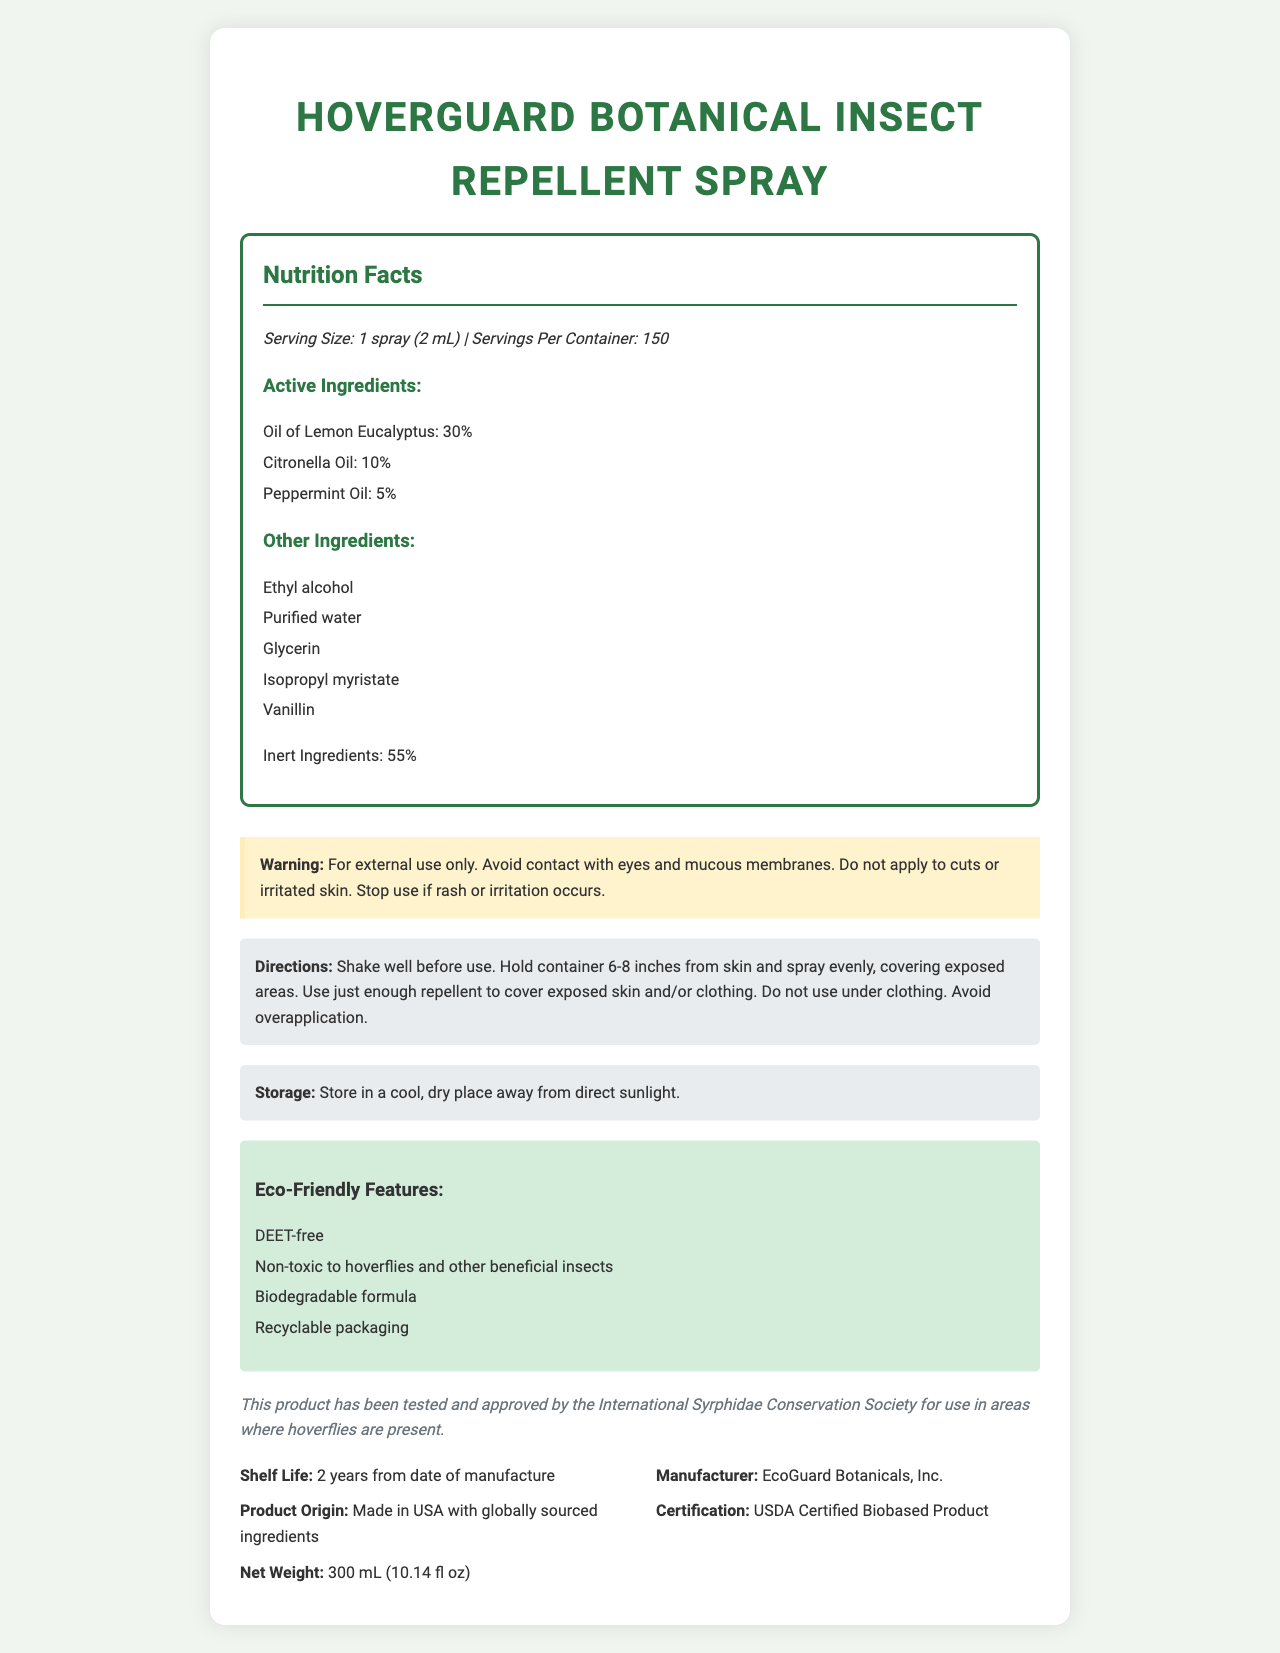what is the name of the product? The product name is prominently displayed as "HoverGuard Botanical Insect Repellent Spray" at the top of the document.
Answer: HoverGuard Botanical Insect Repellent Spray what is the serving size? The serving size is mentioned in the Nutrition Facts section as "Serving Size: 1 spray (2 mL)".
Answer: 1 spray (2 mL) list two active ingredients in the product. The active ingredients listed under the Nutrition Facts section include Oil of Lemon Eucalyptus and Citronella Oil among others.
Answer: Oil of Lemon Eucalyptus, Citronella Oil how many servings are in the container? The document states there are 150 servings per container.
Answer: 150 what is the shelf life of the product? The shelf life is listed as "2 years from date of manufacture" in the product information section.
Answer: 2 years from date of manufacture which ingredient has the highest percentage in the product? A. Citronella Oil B. Oil of Lemon Eucalyptus C. Peppermint Oil The ingredient with the highest percentage is Oil of Lemon Eucalyptus at 30%.
Answer: B what is the net weight of the product? A. 150 mL B. 300 mL C. 100 mL The net weight is indicated as 300 mL (10.14 fl oz) in the product information.
Answer: B is this product safe for hoverflies? The product has been tested and approved by the International Syrphidae Conservation Society for use in areas where hoverflies are present.
Answer: Yes does the product contain DEET? One of the eco-friendly features listed is that the product is DEET-free.
Answer: No summarize the eco-friendly features of this product. The document lists multiple eco-friendly features including being DEET-free, non-toxic to hoverflies and beneficial insects, biodegradable, and packaged in recyclable materials.
Answer: The product is DEET-free, non-toxic to hoverflies and other beneficial insects, has a biodegradable formula, and uses recyclable packaging. where is the product manufactured? The product origin is listed as "Made in USA with globally sourced ingredients" in the product information section.
Answer: Made in USA with globally sourced ingredients how should the spray be applied? The directions section advises users to shake well before use, hold the container 6-8 inches from the skin, spray evenly, cover exposed areas, and avoid overapplication.
Answer: Shake well before use, hold container 6-8 inches from skin and spray evenly, covering exposed areas. Use just enough to cover exposed skin and/or clothing, and avoid overapplication. can I use the spray on irritated skin? The warning section specifies to avoid applying the spray to cuts or irritated skin.
Answer: No name one other ingredient besides active ones. One of the other ingredients listed is Ethyl alcohol.
Answer: Ethyl alcohol who is the manufacturer? The manufacturer is listed as EcoGuard Botanicals, Inc. in the product information.
Answer: EcoGuard Botanicals, Inc. does the document provide information about side effects? The warning section advises to stop use if rash or irritation occurs, indicating potential side effects.
Answer: Yes when should you stop using this product? The warning section indicates to stop use if rash or irritation occurs.
Answer: If rash or irritation occurs what is the correct application distance from the skin? The directions specify holding the container 6-8 inches from the skin when applying the spray.
Answer: 6-8 inches how does this product support hoverfly conservation efforts? The hoverfly conservation section states the product is tested and approved for safety around hoverflies.
Answer: The product has been tested and approved by the International Syrphidae Conservation Society for use in areas where hoverflies are present. what is the percentage of inert ingredients in the product? The percentage of inert ingredients is listed as 55% in the nutrition facts section.
Answer: 55% who certified this product? The certification is mentioned as USDA Certified Biobased Product.
Answer: USDA Certified Biobased Product what does the document say about the product's environmental impact? The eco-friendly features describe the product's positive environmental impact.
Answer: The product is DEET-free, non-toxic to hoverflies and other beneficial insects, biodegradable, and packaged in recyclable materials. name one common use case where the application of this product should be limited. The warning section specifies not to apply to cuts or irritated skin.
Answer: Do not apply to cuts or irritated skin. how long should the product be stored for optimal use? The document specifies a shelf life of 2 years from manufacture but does not provide information on how long the product should ideally be stored before use.
Answer: Cannot be determined 